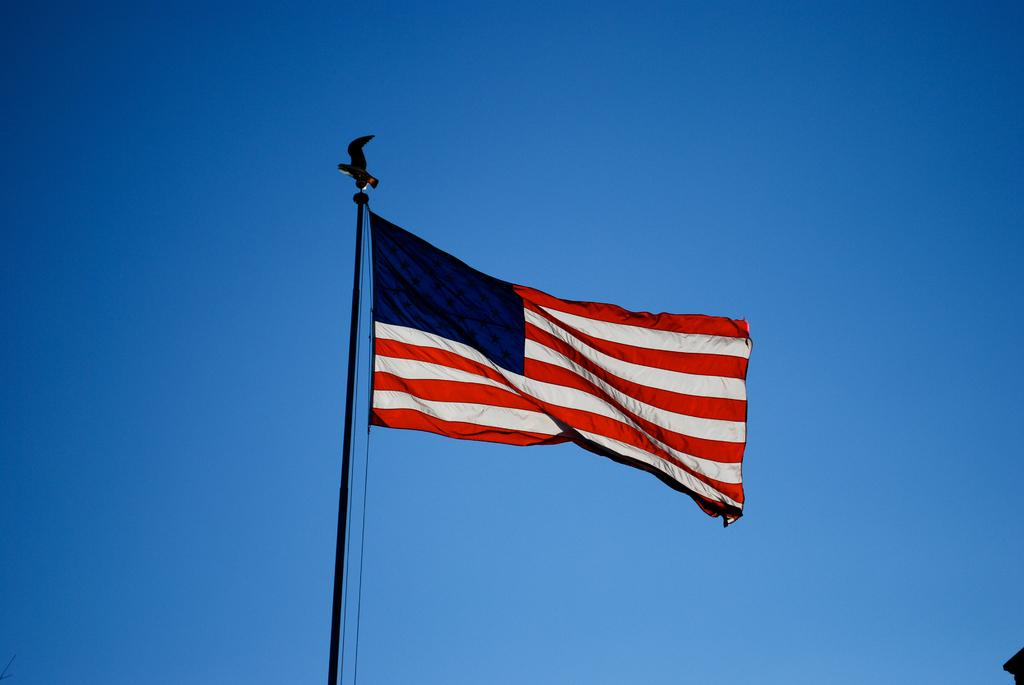What flag is visible in the image? There is a flag of the United States in the image. What can be seen in the background of the image? The sky is visible in the background of the image. How would you describe the sky in the image? The sky appears to be clear in the image. How many loaves of bread are on the flag in the image? There are no loaves of bread present on the flag in the image. What type of hat is worn by the frogs in the image? There are no frogs or hats present in the image. 